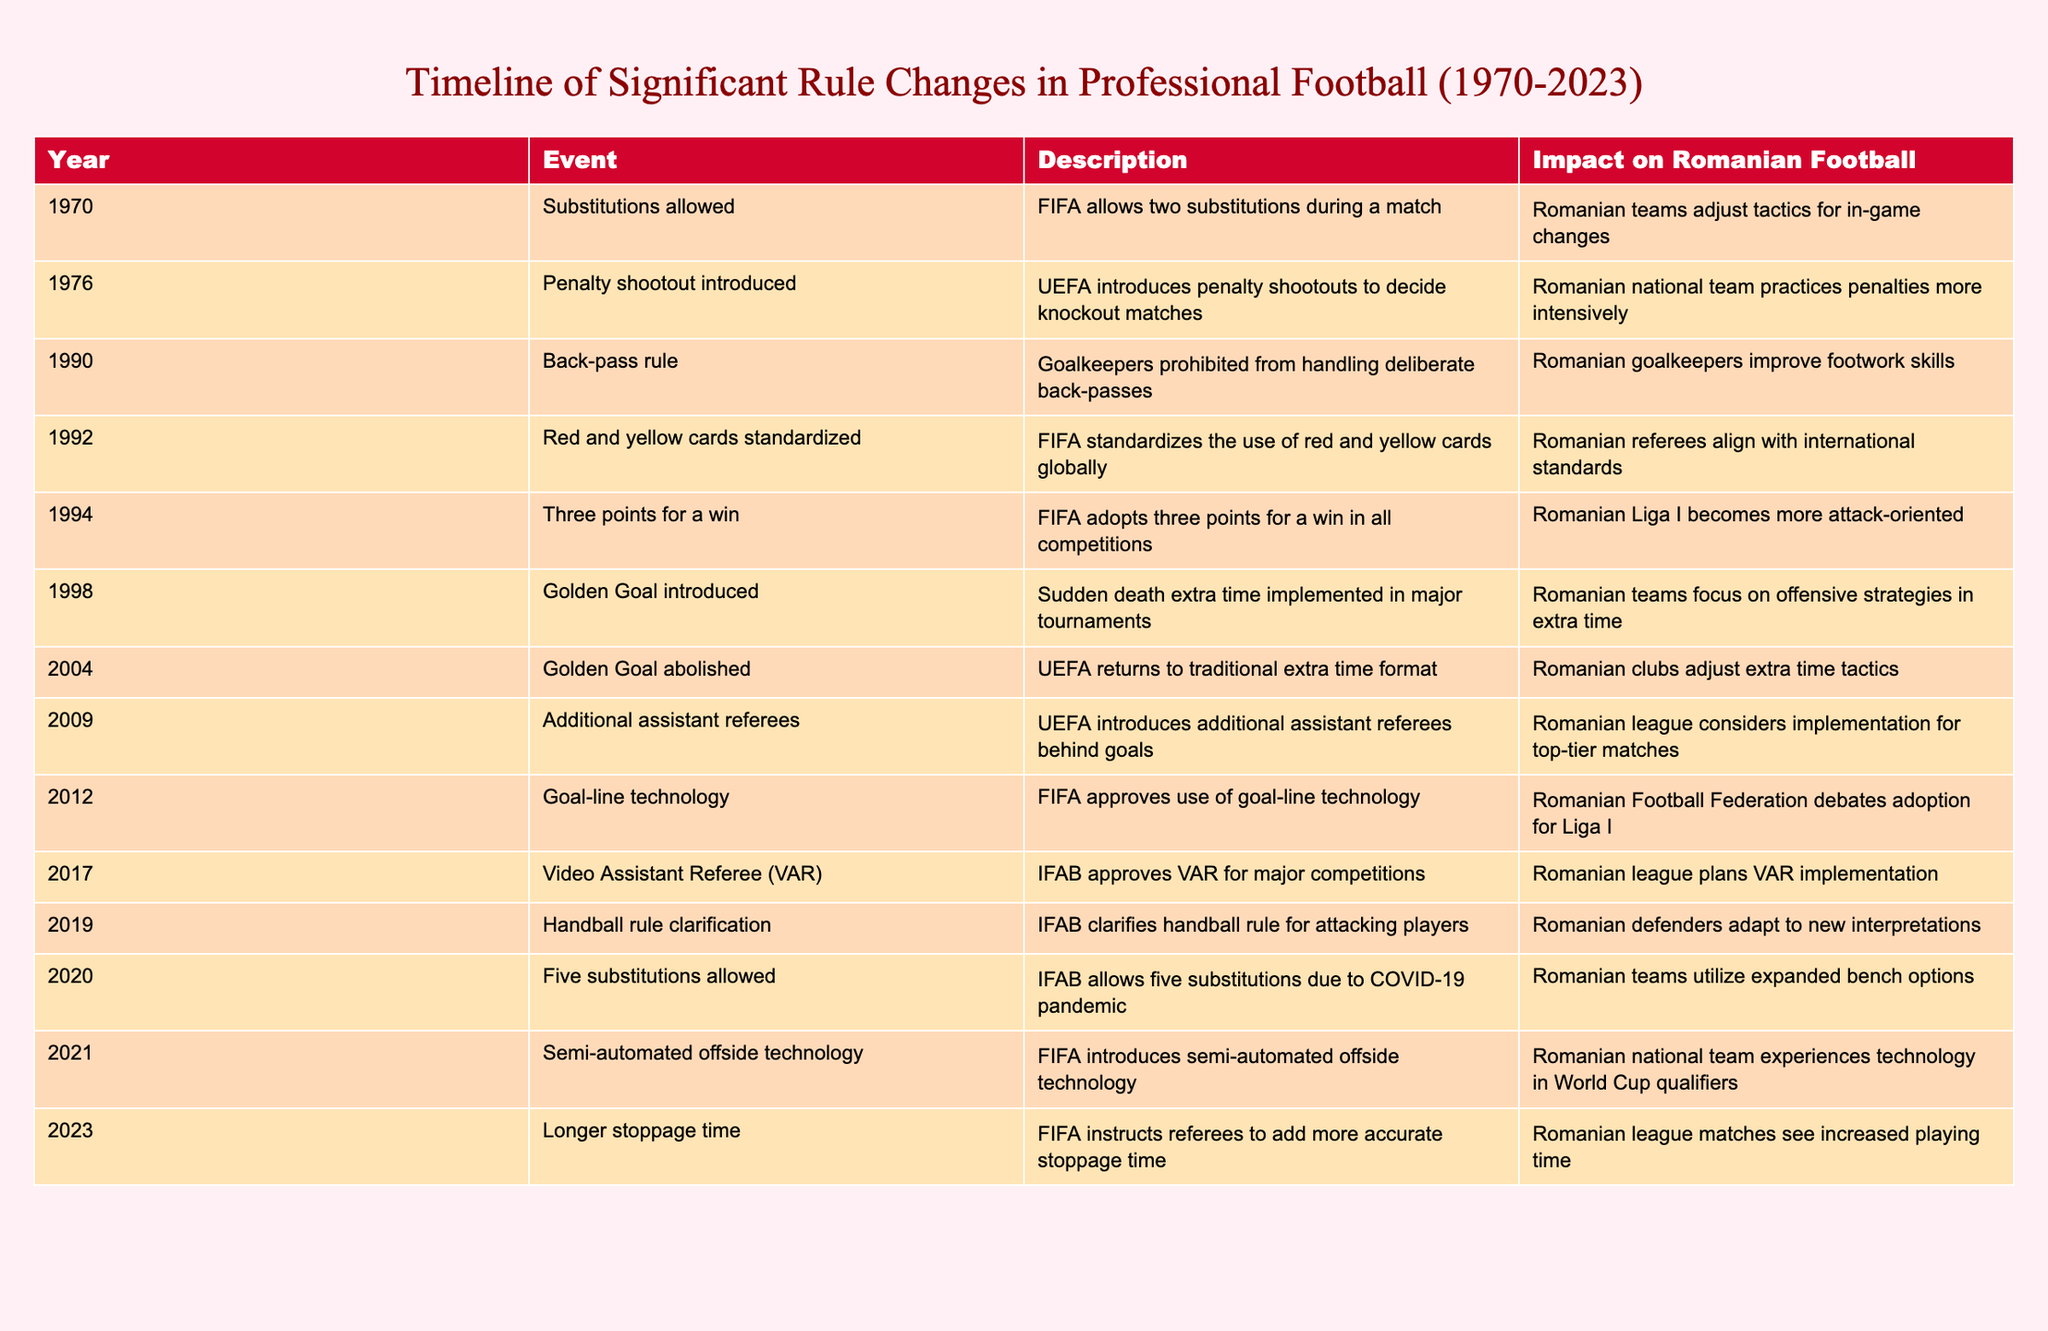What year was the penalty shootout introduced? The table indicates that the penalty shootout was introduced in 1976. It can be found clearly in the "Year" column corresponding to that event.
Answer: 1976 What significant change occurred in 1990, and how did it impact Romanian football? In 1990, the back-pass rule was implemented, prohibiting goalkeepers from handling deliberate back-passes. This change led to Romanian goalkeepers improving their footwork skills, as noted in the "Impact on Romanian Football" column.
Answer: Back-pass rule; improved footwork skills Did the introduction of the VAR happen before or after the adoption of goal-line technology? VAR was introduced in 2017, while goal-line technology was approved in 2012. Since 2017 is later than 2012, VAR was introduced after goal-line technology.
Answer: After How many significant rule changes allowed for more substitutions? The table indicates two events that allowed more substitutions: in 2020, five substitutions were permitted due to COVID-19, and prior to that, two substitutions were allowed starting in 1970. Therefore, there were two significant changes allowing for more substitutions.
Answer: 2 Which events led to Romanian teams focusing on offensive strategies, and in what years did they occur? The table shows two significant events that prompted Romanian teams to focus on offense. The first was the introduction of the three points for a win rule in 1994, and the second was the adoption of the golden goal in 1998. These events are explicitly mentioned in the "Description" column.
Answer: 1994 and 1998 What is the overall trend regarding the allowance of substitutions from 1970 to 2020? Starting with two substitutions allowed in 1970, the rule changed in 2020 to allow five substitutions, indicating a trend towards more player rotation and tactical options during matches. This can be observed by comparing the entries for those years.
Answer: Increasing substitutions Was there a time when Romanian football was directly influenced by the introduction of additional assistant referees? Yes, the introduction of additional assistant referees in 2009 had a noted impact, as the table states that Romanian league officials considered implementing this rule for top-tier matches.
Answer: Yes In which year did the longest stoppage time rule come into effect, and what was its effect? The longest stoppage time rule was instructed by FIFA in 2023. The effect noted in the table is that Romanian league matches saw increased playing time as a result.
Answer: 2023; increased playing time 